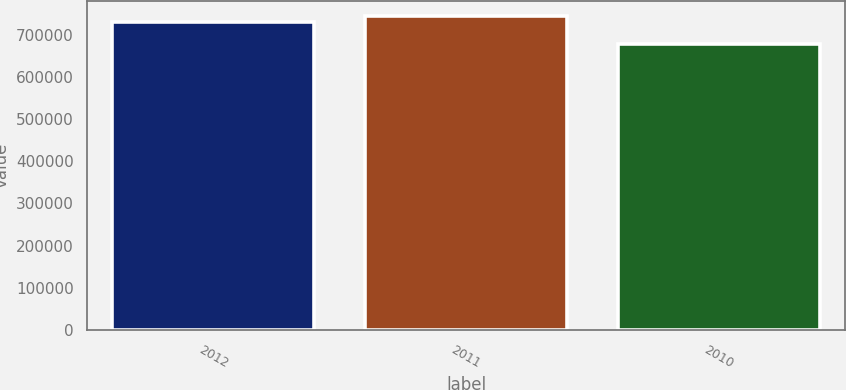Convert chart to OTSL. <chart><loc_0><loc_0><loc_500><loc_500><bar_chart><fcel>2012<fcel>2011<fcel>2010<nl><fcel>730489<fcel>743308<fcel>676738<nl></chart> 